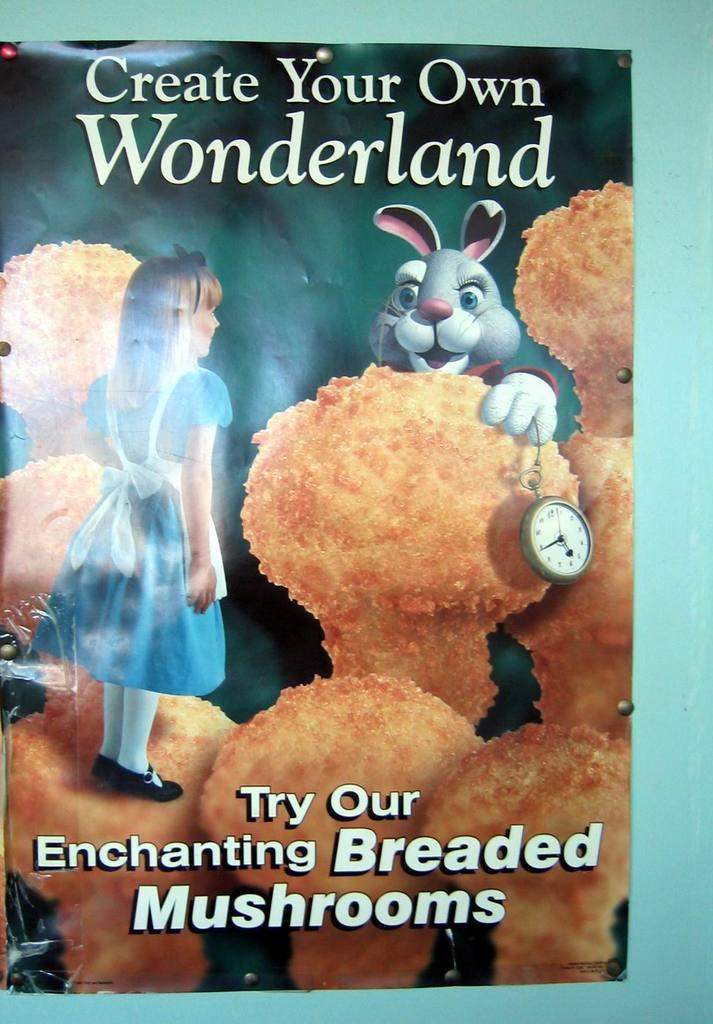Provide a one-sentence caption for the provided image. A book with a girl and a rabbit on the front that says Create Your Own Wonderland. 